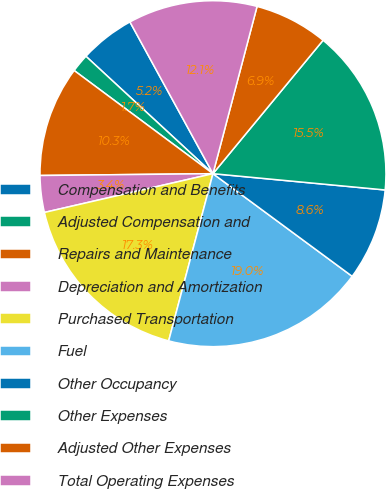Convert chart to OTSL. <chart><loc_0><loc_0><loc_500><loc_500><pie_chart><fcel>Compensation and Benefits<fcel>Adjusted Compensation and<fcel>Repairs and Maintenance<fcel>Depreciation and Amortization<fcel>Purchased Transportation<fcel>Fuel<fcel>Other Occupancy<fcel>Other Expenses<fcel>Adjusted Other Expenses<fcel>Total Operating Expenses<nl><fcel>5.16%<fcel>1.7%<fcel>10.34%<fcel>3.43%<fcel>17.28%<fcel>19.01%<fcel>8.61%<fcel>15.52%<fcel>6.88%<fcel>12.07%<nl></chart> 